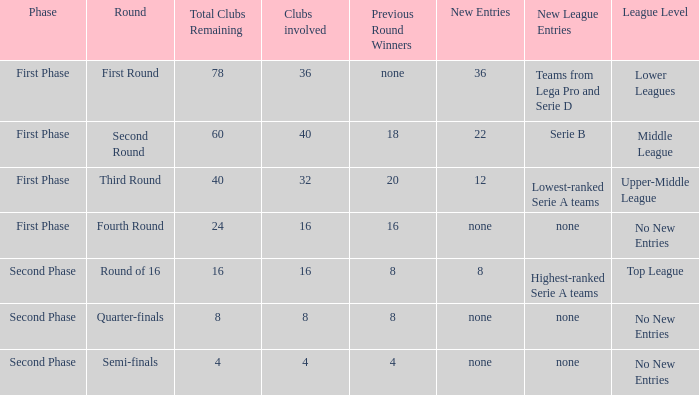If there are 8 clubs involved, what number would you discover from the winners of the previous round? 8.0. 